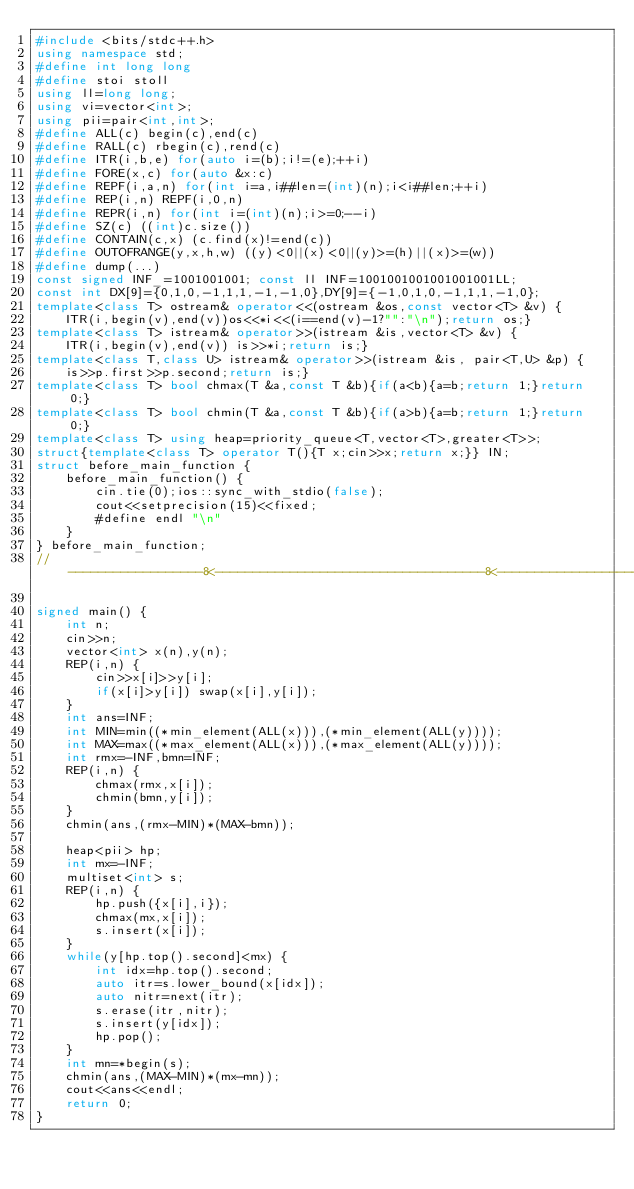Convert code to text. <code><loc_0><loc_0><loc_500><loc_500><_C++_>#include <bits/stdc++.h>
using namespace std;
#define int long long
#define stoi stoll
using ll=long long;
using vi=vector<int>;
using pii=pair<int,int>;
#define ALL(c) begin(c),end(c)
#define RALL(c) rbegin(c),rend(c)
#define ITR(i,b,e) for(auto i=(b);i!=(e);++i)
#define FORE(x,c) for(auto &x:c)
#define REPF(i,a,n) for(int i=a,i##len=(int)(n);i<i##len;++i)
#define REP(i,n) REPF(i,0,n)
#define REPR(i,n) for(int i=(int)(n);i>=0;--i)
#define SZ(c) ((int)c.size())
#define CONTAIN(c,x) (c.find(x)!=end(c))
#define OUTOFRANGE(y,x,h,w) ((y)<0||(x)<0||(y)>=(h)||(x)>=(w))
#define dump(...)
const signed INF_=1001001001; const ll INF=1001001001001001001LL;
const int DX[9]={0,1,0,-1,1,1,-1,-1,0},DY[9]={-1,0,1,0,-1,1,1,-1,0};
template<class T> ostream& operator<<(ostream &os,const vector<T> &v) {
    ITR(i,begin(v),end(v))os<<*i<<(i==end(v)-1?"":"\n");return os;}
template<class T> istream& operator>>(istream &is,vector<T> &v) {
    ITR(i,begin(v),end(v)) is>>*i;return is;}
template<class T,class U> istream& operator>>(istream &is, pair<T,U> &p) {
    is>>p.first>>p.second;return is;}
template<class T> bool chmax(T &a,const T &b){if(a<b){a=b;return 1;}return 0;}
template<class T> bool chmin(T &a,const T &b){if(a>b){a=b;return 1;}return 0;}
template<class T> using heap=priority_queue<T,vector<T>,greater<T>>;
struct{template<class T> operator T(){T x;cin>>x;return x;}} IN;
struct before_main_function {
    before_main_function() {
        cin.tie(0);ios::sync_with_stdio(false);
        cout<<setprecision(15)<<fixed;
        #define endl "\n"
    }
} before_main_function;
//------------------8<------------------------------------8<--------------------

signed main() {
    int n;
    cin>>n;
    vector<int> x(n),y(n);
    REP(i,n) {
        cin>>x[i]>>y[i];
        if(x[i]>y[i]) swap(x[i],y[i]);
    }
    int ans=INF;
    int MIN=min((*min_element(ALL(x))),(*min_element(ALL(y))));
    int MAX=max((*max_element(ALL(x))),(*max_element(ALL(y))));
    int rmx=-INF,bmn=INF;
    REP(i,n) {
        chmax(rmx,x[i]);
        chmin(bmn,y[i]);
    }
    chmin(ans,(rmx-MIN)*(MAX-bmn));

    heap<pii> hp;
    int mx=-INF;
    multiset<int> s;
    REP(i,n) {
        hp.push({x[i],i});
        chmax(mx,x[i]);
        s.insert(x[i]);
    }
    while(y[hp.top().second]<mx) {
        int idx=hp.top().second;
        auto itr=s.lower_bound(x[idx]);
        auto nitr=next(itr);
        s.erase(itr,nitr);
        s.insert(y[idx]);
        hp.pop();
    }
    int mn=*begin(s);
    chmin(ans,(MAX-MIN)*(mx-mn));
    cout<<ans<<endl;
    return 0;
}

</code> 